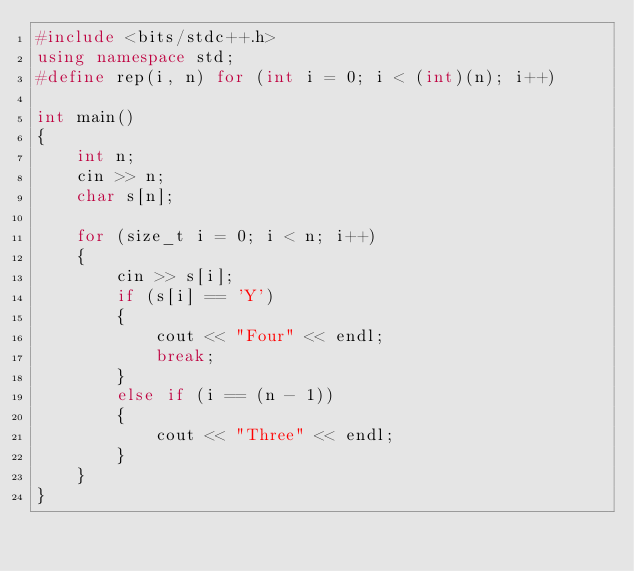<code> <loc_0><loc_0><loc_500><loc_500><_C++_>#include <bits/stdc++.h>
using namespace std;
#define rep(i, n) for (int i = 0; i < (int)(n); i++)

int main()
{
    int n;
    cin >> n;
    char s[n];

    for (size_t i = 0; i < n; i++)
    {
        cin >> s[i];
        if (s[i] == 'Y')
        {
            cout << "Four" << endl;
            break;
        }
        else if (i == (n - 1))
        {
            cout << "Three" << endl;
        }
    }
}
</code> 